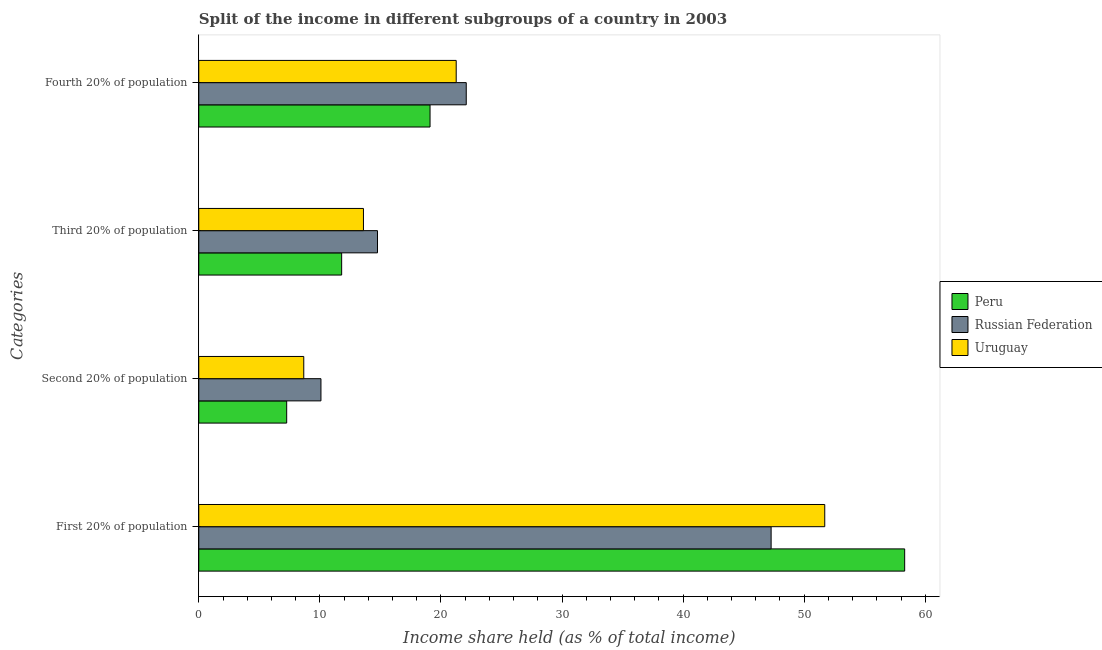How many different coloured bars are there?
Offer a very short reply. 3. How many groups of bars are there?
Offer a very short reply. 4. Are the number of bars on each tick of the Y-axis equal?
Give a very brief answer. Yes. How many bars are there on the 3rd tick from the top?
Provide a short and direct response. 3. What is the label of the 2nd group of bars from the top?
Your answer should be very brief. Third 20% of population. Across all countries, what is the maximum share of the income held by second 20% of the population?
Your response must be concise. 10.09. Across all countries, what is the minimum share of the income held by second 20% of the population?
Your answer should be very brief. 7.26. In which country was the share of the income held by third 20% of the population maximum?
Keep it short and to the point. Russian Federation. What is the total share of the income held by first 20% of the population in the graph?
Your answer should be very brief. 157.27. What is the difference between the share of the income held by second 20% of the population in Russian Federation and that in Peru?
Offer a terse response. 2.83. What is the difference between the share of the income held by third 20% of the population in Peru and the share of the income held by second 20% of the population in Russian Federation?
Offer a very short reply. 1.71. What is the average share of the income held by fourth 20% of the population per country?
Provide a succinct answer. 20.82. What is the difference between the share of the income held by first 20% of the population and share of the income held by third 20% of the population in Uruguay?
Your answer should be compact. 38.1. In how many countries, is the share of the income held by first 20% of the population greater than 30 %?
Give a very brief answer. 3. What is the ratio of the share of the income held by fourth 20% of the population in Peru to that in Uruguay?
Keep it short and to the point. 0.9. Is the share of the income held by third 20% of the population in Russian Federation less than that in Uruguay?
Offer a very short reply. No. Is the difference between the share of the income held by second 20% of the population in Peru and Russian Federation greater than the difference between the share of the income held by third 20% of the population in Peru and Russian Federation?
Offer a very short reply. Yes. What is the difference between the highest and the second highest share of the income held by first 20% of the population?
Give a very brief answer. 6.6. What is the difference between the highest and the lowest share of the income held by third 20% of the population?
Your answer should be compact. 2.96. In how many countries, is the share of the income held by second 20% of the population greater than the average share of the income held by second 20% of the population taken over all countries?
Your answer should be very brief. 1. What does the 3rd bar from the top in Fourth 20% of population represents?
Your answer should be compact. Peru. What does the 3rd bar from the bottom in Third 20% of population represents?
Provide a short and direct response. Uruguay. Is it the case that in every country, the sum of the share of the income held by first 20% of the population and share of the income held by second 20% of the population is greater than the share of the income held by third 20% of the population?
Your response must be concise. Yes. How many countries are there in the graph?
Your answer should be very brief. 3. Are the values on the major ticks of X-axis written in scientific E-notation?
Your response must be concise. No. Does the graph contain any zero values?
Give a very brief answer. No. How are the legend labels stacked?
Your answer should be compact. Vertical. What is the title of the graph?
Provide a short and direct response. Split of the income in different subgroups of a country in 2003. Does "Finland" appear as one of the legend labels in the graph?
Offer a terse response. No. What is the label or title of the X-axis?
Offer a terse response. Income share held (as % of total income). What is the label or title of the Y-axis?
Keep it short and to the point. Categories. What is the Income share held (as % of total income) in Peru in First 20% of population?
Make the answer very short. 58.3. What is the Income share held (as % of total income) in Russian Federation in First 20% of population?
Make the answer very short. 47.27. What is the Income share held (as % of total income) in Uruguay in First 20% of population?
Provide a short and direct response. 51.7. What is the Income share held (as % of total income) in Peru in Second 20% of population?
Give a very brief answer. 7.26. What is the Income share held (as % of total income) of Russian Federation in Second 20% of population?
Make the answer very short. 10.09. What is the Income share held (as % of total income) in Uruguay in Second 20% of population?
Your answer should be very brief. 8.67. What is the Income share held (as % of total income) of Peru in Third 20% of population?
Provide a short and direct response. 11.8. What is the Income share held (as % of total income) in Russian Federation in Third 20% of population?
Provide a short and direct response. 14.76. What is the Income share held (as % of total income) of Uruguay in Third 20% of population?
Offer a very short reply. 13.6. What is the Income share held (as % of total income) in Russian Federation in Fourth 20% of population?
Offer a very short reply. 22.09. What is the Income share held (as % of total income) in Uruguay in Fourth 20% of population?
Provide a short and direct response. 21.26. Across all Categories, what is the maximum Income share held (as % of total income) in Peru?
Offer a very short reply. 58.3. Across all Categories, what is the maximum Income share held (as % of total income) of Russian Federation?
Keep it short and to the point. 47.27. Across all Categories, what is the maximum Income share held (as % of total income) of Uruguay?
Make the answer very short. 51.7. Across all Categories, what is the minimum Income share held (as % of total income) of Peru?
Provide a short and direct response. 7.26. Across all Categories, what is the minimum Income share held (as % of total income) of Russian Federation?
Offer a terse response. 10.09. Across all Categories, what is the minimum Income share held (as % of total income) of Uruguay?
Keep it short and to the point. 8.67. What is the total Income share held (as % of total income) of Peru in the graph?
Make the answer very short. 96.46. What is the total Income share held (as % of total income) in Russian Federation in the graph?
Offer a terse response. 94.21. What is the total Income share held (as % of total income) of Uruguay in the graph?
Your response must be concise. 95.23. What is the difference between the Income share held (as % of total income) of Peru in First 20% of population and that in Second 20% of population?
Provide a succinct answer. 51.04. What is the difference between the Income share held (as % of total income) in Russian Federation in First 20% of population and that in Second 20% of population?
Keep it short and to the point. 37.18. What is the difference between the Income share held (as % of total income) of Uruguay in First 20% of population and that in Second 20% of population?
Provide a short and direct response. 43.03. What is the difference between the Income share held (as % of total income) of Peru in First 20% of population and that in Third 20% of population?
Keep it short and to the point. 46.5. What is the difference between the Income share held (as % of total income) of Russian Federation in First 20% of population and that in Third 20% of population?
Your answer should be compact. 32.51. What is the difference between the Income share held (as % of total income) of Uruguay in First 20% of population and that in Third 20% of population?
Make the answer very short. 38.1. What is the difference between the Income share held (as % of total income) of Peru in First 20% of population and that in Fourth 20% of population?
Your response must be concise. 39.2. What is the difference between the Income share held (as % of total income) of Russian Federation in First 20% of population and that in Fourth 20% of population?
Give a very brief answer. 25.18. What is the difference between the Income share held (as % of total income) of Uruguay in First 20% of population and that in Fourth 20% of population?
Offer a terse response. 30.44. What is the difference between the Income share held (as % of total income) of Peru in Second 20% of population and that in Third 20% of population?
Provide a short and direct response. -4.54. What is the difference between the Income share held (as % of total income) in Russian Federation in Second 20% of population and that in Third 20% of population?
Your response must be concise. -4.67. What is the difference between the Income share held (as % of total income) of Uruguay in Second 20% of population and that in Third 20% of population?
Keep it short and to the point. -4.93. What is the difference between the Income share held (as % of total income) in Peru in Second 20% of population and that in Fourth 20% of population?
Give a very brief answer. -11.84. What is the difference between the Income share held (as % of total income) in Russian Federation in Second 20% of population and that in Fourth 20% of population?
Provide a short and direct response. -12. What is the difference between the Income share held (as % of total income) in Uruguay in Second 20% of population and that in Fourth 20% of population?
Your answer should be very brief. -12.59. What is the difference between the Income share held (as % of total income) of Russian Federation in Third 20% of population and that in Fourth 20% of population?
Offer a terse response. -7.33. What is the difference between the Income share held (as % of total income) in Uruguay in Third 20% of population and that in Fourth 20% of population?
Make the answer very short. -7.66. What is the difference between the Income share held (as % of total income) of Peru in First 20% of population and the Income share held (as % of total income) of Russian Federation in Second 20% of population?
Provide a succinct answer. 48.21. What is the difference between the Income share held (as % of total income) in Peru in First 20% of population and the Income share held (as % of total income) in Uruguay in Second 20% of population?
Ensure brevity in your answer.  49.63. What is the difference between the Income share held (as % of total income) in Russian Federation in First 20% of population and the Income share held (as % of total income) in Uruguay in Second 20% of population?
Keep it short and to the point. 38.6. What is the difference between the Income share held (as % of total income) of Peru in First 20% of population and the Income share held (as % of total income) of Russian Federation in Third 20% of population?
Make the answer very short. 43.54. What is the difference between the Income share held (as % of total income) in Peru in First 20% of population and the Income share held (as % of total income) in Uruguay in Third 20% of population?
Offer a terse response. 44.7. What is the difference between the Income share held (as % of total income) of Russian Federation in First 20% of population and the Income share held (as % of total income) of Uruguay in Third 20% of population?
Provide a short and direct response. 33.67. What is the difference between the Income share held (as % of total income) in Peru in First 20% of population and the Income share held (as % of total income) in Russian Federation in Fourth 20% of population?
Keep it short and to the point. 36.21. What is the difference between the Income share held (as % of total income) in Peru in First 20% of population and the Income share held (as % of total income) in Uruguay in Fourth 20% of population?
Ensure brevity in your answer.  37.04. What is the difference between the Income share held (as % of total income) of Russian Federation in First 20% of population and the Income share held (as % of total income) of Uruguay in Fourth 20% of population?
Make the answer very short. 26.01. What is the difference between the Income share held (as % of total income) in Peru in Second 20% of population and the Income share held (as % of total income) in Russian Federation in Third 20% of population?
Offer a terse response. -7.5. What is the difference between the Income share held (as % of total income) of Peru in Second 20% of population and the Income share held (as % of total income) of Uruguay in Third 20% of population?
Make the answer very short. -6.34. What is the difference between the Income share held (as % of total income) of Russian Federation in Second 20% of population and the Income share held (as % of total income) of Uruguay in Third 20% of population?
Make the answer very short. -3.51. What is the difference between the Income share held (as % of total income) of Peru in Second 20% of population and the Income share held (as % of total income) of Russian Federation in Fourth 20% of population?
Your response must be concise. -14.83. What is the difference between the Income share held (as % of total income) of Russian Federation in Second 20% of population and the Income share held (as % of total income) of Uruguay in Fourth 20% of population?
Keep it short and to the point. -11.17. What is the difference between the Income share held (as % of total income) in Peru in Third 20% of population and the Income share held (as % of total income) in Russian Federation in Fourth 20% of population?
Ensure brevity in your answer.  -10.29. What is the difference between the Income share held (as % of total income) in Peru in Third 20% of population and the Income share held (as % of total income) in Uruguay in Fourth 20% of population?
Provide a short and direct response. -9.46. What is the average Income share held (as % of total income) of Peru per Categories?
Make the answer very short. 24.11. What is the average Income share held (as % of total income) of Russian Federation per Categories?
Keep it short and to the point. 23.55. What is the average Income share held (as % of total income) of Uruguay per Categories?
Offer a terse response. 23.81. What is the difference between the Income share held (as % of total income) in Peru and Income share held (as % of total income) in Russian Federation in First 20% of population?
Offer a very short reply. 11.03. What is the difference between the Income share held (as % of total income) of Peru and Income share held (as % of total income) of Uruguay in First 20% of population?
Your response must be concise. 6.6. What is the difference between the Income share held (as % of total income) in Russian Federation and Income share held (as % of total income) in Uruguay in First 20% of population?
Provide a succinct answer. -4.43. What is the difference between the Income share held (as % of total income) in Peru and Income share held (as % of total income) in Russian Federation in Second 20% of population?
Provide a short and direct response. -2.83. What is the difference between the Income share held (as % of total income) of Peru and Income share held (as % of total income) of Uruguay in Second 20% of population?
Your response must be concise. -1.41. What is the difference between the Income share held (as % of total income) of Russian Federation and Income share held (as % of total income) of Uruguay in Second 20% of population?
Provide a succinct answer. 1.42. What is the difference between the Income share held (as % of total income) of Peru and Income share held (as % of total income) of Russian Federation in Third 20% of population?
Your response must be concise. -2.96. What is the difference between the Income share held (as % of total income) of Russian Federation and Income share held (as % of total income) of Uruguay in Third 20% of population?
Ensure brevity in your answer.  1.16. What is the difference between the Income share held (as % of total income) of Peru and Income share held (as % of total income) of Russian Federation in Fourth 20% of population?
Your response must be concise. -2.99. What is the difference between the Income share held (as % of total income) of Peru and Income share held (as % of total income) of Uruguay in Fourth 20% of population?
Keep it short and to the point. -2.16. What is the difference between the Income share held (as % of total income) in Russian Federation and Income share held (as % of total income) in Uruguay in Fourth 20% of population?
Keep it short and to the point. 0.83. What is the ratio of the Income share held (as % of total income) of Peru in First 20% of population to that in Second 20% of population?
Give a very brief answer. 8.03. What is the ratio of the Income share held (as % of total income) in Russian Federation in First 20% of population to that in Second 20% of population?
Your answer should be very brief. 4.68. What is the ratio of the Income share held (as % of total income) in Uruguay in First 20% of population to that in Second 20% of population?
Ensure brevity in your answer.  5.96. What is the ratio of the Income share held (as % of total income) in Peru in First 20% of population to that in Third 20% of population?
Make the answer very short. 4.94. What is the ratio of the Income share held (as % of total income) in Russian Federation in First 20% of population to that in Third 20% of population?
Offer a very short reply. 3.2. What is the ratio of the Income share held (as % of total income) in Uruguay in First 20% of population to that in Third 20% of population?
Your answer should be compact. 3.8. What is the ratio of the Income share held (as % of total income) of Peru in First 20% of population to that in Fourth 20% of population?
Keep it short and to the point. 3.05. What is the ratio of the Income share held (as % of total income) of Russian Federation in First 20% of population to that in Fourth 20% of population?
Provide a succinct answer. 2.14. What is the ratio of the Income share held (as % of total income) in Uruguay in First 20% of population to that in Fourth 20% of population?
Your answer should be compact. 2.43. What is the ratio of the Income share held (as % of total income) of Peru in Second 20% of population to that in Third 20% of population?
Provide a short and direct response. 0.62. What is the ratio of the Income share held (as % of total income) in Russian Federation in Second 20% of population to that in Third 20% of population?
Your answer should be compact. 0.68. What is the ratio of the Income share held (as % of total income) of Uruguay in Second 20% of population to that in Third 20% of population?
Provide a succinct answer. 0.64. What is the ratio of the Income share held (as % of total income) of Peru in Second 20% of population to that in Fourth 20% of population?
Your response must be concise. 0.38. What is the ratio of the Income share held (as % of total income) of Russian Federation in Second 20% of population to that in Fourth 20% of population?
Offer a terse response. 0.46. What is the ratio of the Income share held (as % of total income) of Uruguay in Second 20% of population to that in Fourth 20% of population?
Provide a succinct answer. 0.41. What is the ratio of the Income share held (as % of total income) of Peru in Third 20% of population to that in Fourth 20% of population?
Your answer should be compact. 0.62. What is the ratio of the Income share held (as % of total income) in Russian Federation in Third 20% of population to that in Fourth 20% of population?
Ensure brevity in your answer.  0.67. What is the ratio of the Income share held (as % of total income) of Uruguay in Third 20% of population to that in Fourth 20% of population?
Give a very brief answer. 0.64. What is the difference between the highest and the second highest Income share held (as % of total income) of Peru?
Keep it short and to the point. 39.2. What is the difference between the highest and the second highest Income share held (as % of total income) in Russian Federation?
Keep it short and to the point. 25.18. What is the difference between the highest and the second highest Income share held (as % of total income) of Uruguay?
Offer a terse response. 30.44. What is the difference between the highest and the lowest Income share held (as % of total income) of Peru?
Offer a very short reply. 51.04. What is the difference between the highest and the lowest Income share held (as % of total income) in Russian Federation?
Your answer should be very brief. 37.18. What is the difference between the highest and the lowest Income share held (as % of total income) of Uruguay?
Give a very brief answer. 43.03. 